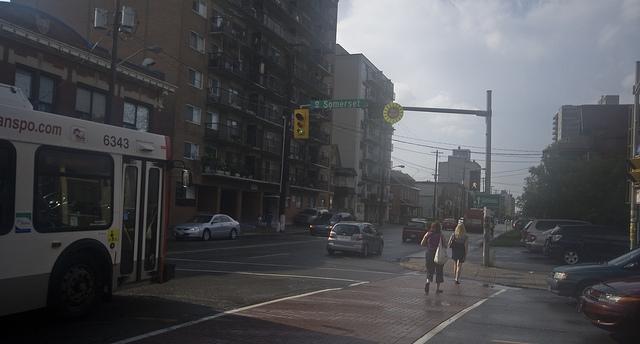Why is the street shiny?
Indicate the correct choice and explain in the format: 'Answer: answer
Rationale: rationale.'
Options: Just rained, newly topped, bright sunshine, just painted. Answer: just rained.
Rationale: The surface is shiny due to wetness, because it has recently rained. 